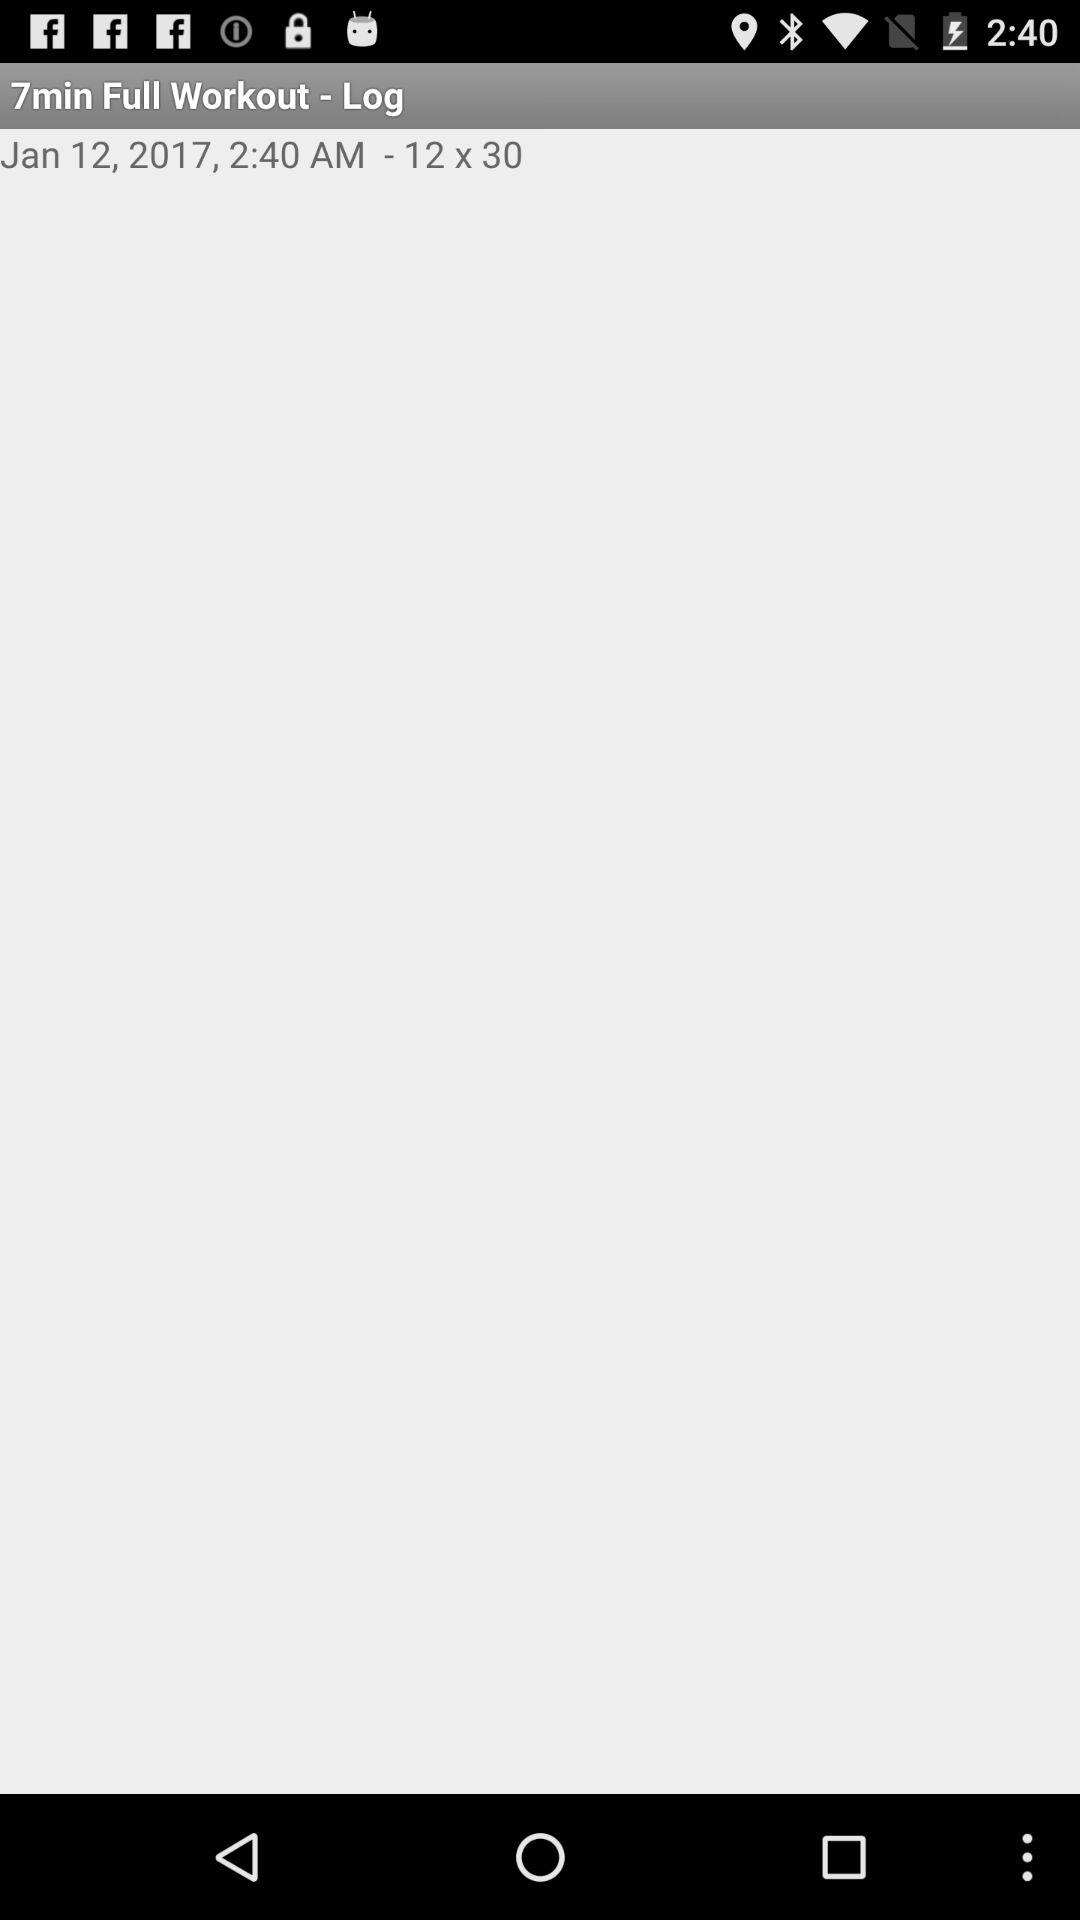What is the time? The time is 2:40 a.m. 